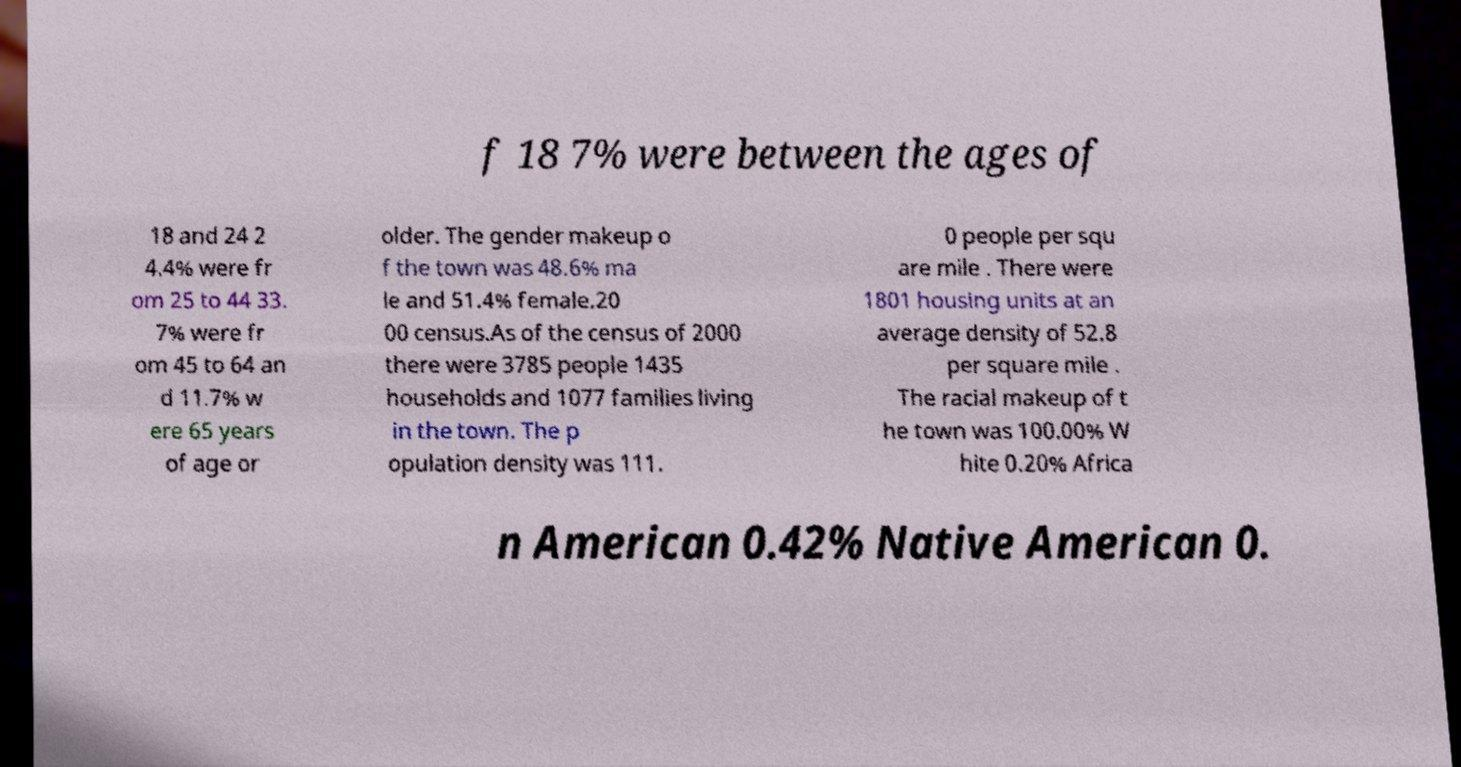For documentation purposes, I need the text within this image transcribed. Could you provide that? f 18 7% were between the ages of 18 and 24 2 4.4% were fr om 25 to 44 33. 7% were fr om 45 to 64 an d 11.7% w ere 65 years of age or older. The gender makeup o f the town was 48.6% ma le and 51.4% female.20 00 census.As of the census of 2000 there were 3785 people 1435 households and 1077 families living in the town. The p opulation density was 111. 0 people per squ are mile . There were 1801 housing units at an average density of 52.8 per square mile . The racial makeup of t he town was 100.00% W hite 0.20% Africa n American 0.42% Native American 0. 